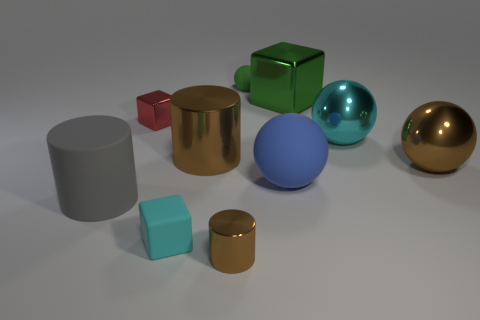Do the green object to the left of the green metallic cube and the large brown cylinder have the same material?
Make the answer very short. No. Are there an equal number of gray cylinders that are to the right of the big metallic cube and big green blocks behind the blue rubber object?
Ensure brevity in your answer.  No. What size is the brown cylinder that is in front of the metallic cylinder behind the gray thing?
Ensure brevity in your answer.  Small. There is a small thing that is behind the blue matte thing and in front of the big green metallic block; what material is it?
Your answer should be compact. Metal. How many other objects are there of the same size as the blue rubber object?
Your answer should be very brief. 5. The small rubber sphere has what color?
Provide a succinct answer. Green. There is a small rubber ball to the left of the green cube; is it the same color as the cube to the right of the blue sphere?
Your answer should be compact. Yes. The matte cube is what size?
Provide a succinct answer. Small. What is the size of the rubber ball that is behind the large green thing?
Your answer should be very brief. Small. What is the shape of the thing that is both in front of the big gray cylinder and to the right of the rubber cube?
Offer a very short reply. Cylinder. 